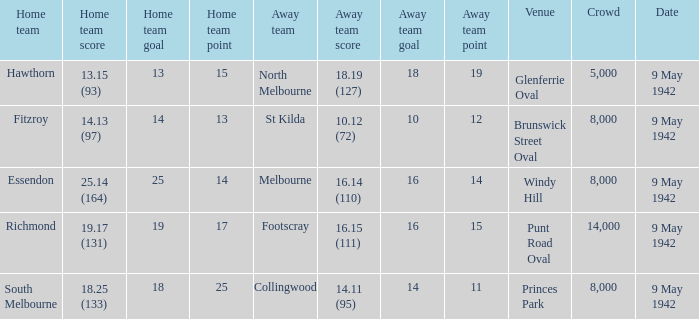How large was the crowd with a home team score of 18.25 (133)? 8000.0. 